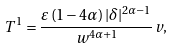<formula> <loc_0><loc_0><loc_500><loc_500>T ^ { 1 } = \frac { \varepsilon \left ( 1 - 4 \alpha \right ) | \delta | ^ { 2 \alpha - 1 } } { w ^ { 4 \alpha + 1 } } v ,</formula> 